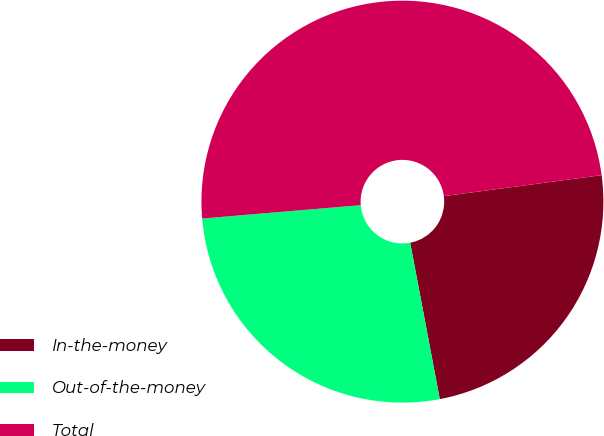Convert chart. <chart><loc_0><loc_0><loc_500><loc_500><pie_chart><fcel>In-the-money<fcel>Out-of-the-money<fcel>Total<nl><fcel>24.13%<fcel>26.64%<fcel>49.24%<nl></chart> 